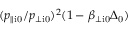<formula> <loc_0><loc_0><loc_500><loc_500>( p _ { \| i 0 } / p _ { \perp i 0 } ) ^ { 2 } ( 1 - \beta _ { \perp i 0 } \Delta _ { 0 } )</formula> 